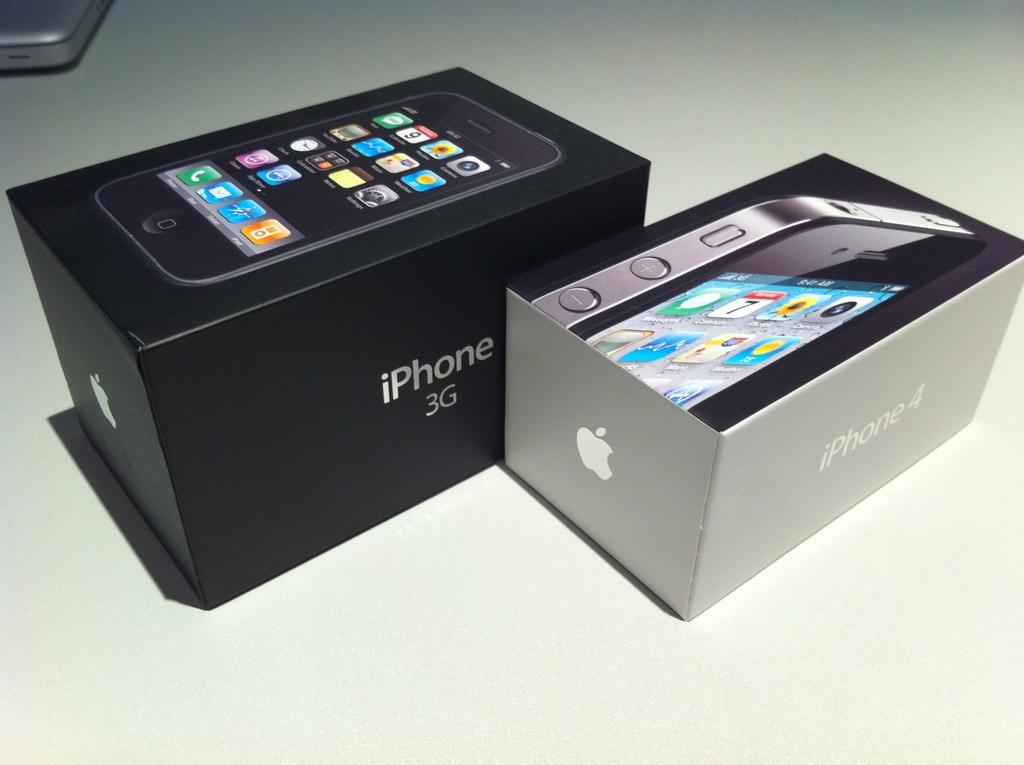<image>
Summarize the visual content of the image. A black box with the iPhone 3G logo sits next to a silver box with the iPhone 4 logo. 